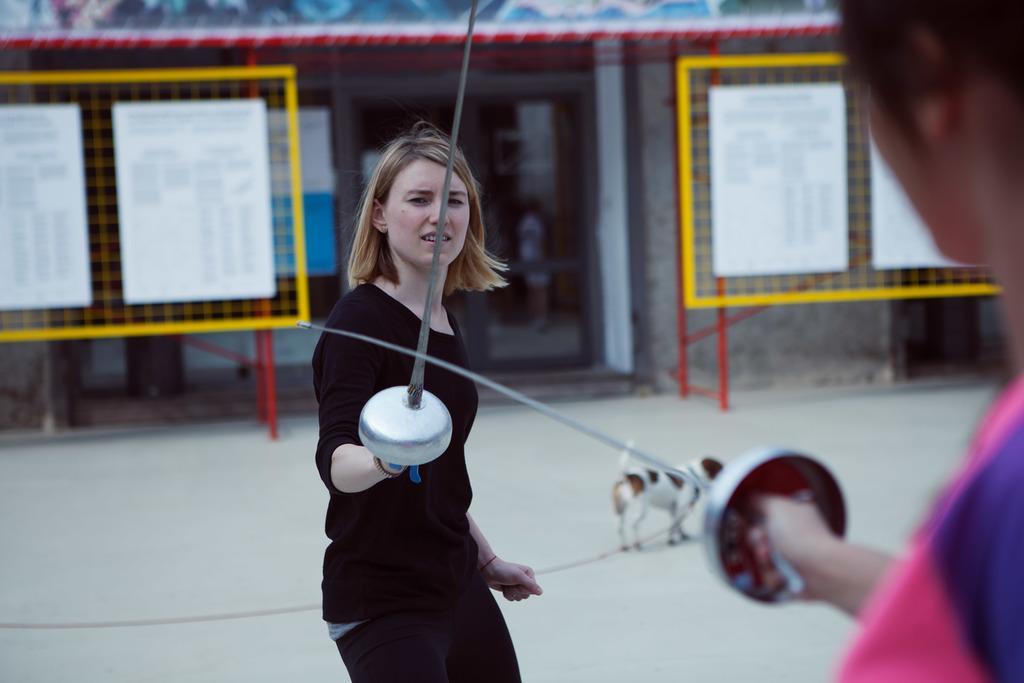How would you summarize this image in a sentence or two? In this image we can see two persons standing on the floor and holding swords in one of their hands. In addition to these in the image we can see a grill board, walls, pillars and a dog. 